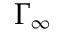<formula> <loc_0><loc_0><loc_500><loc_500>\Gamma _ { \infty }</formula> 